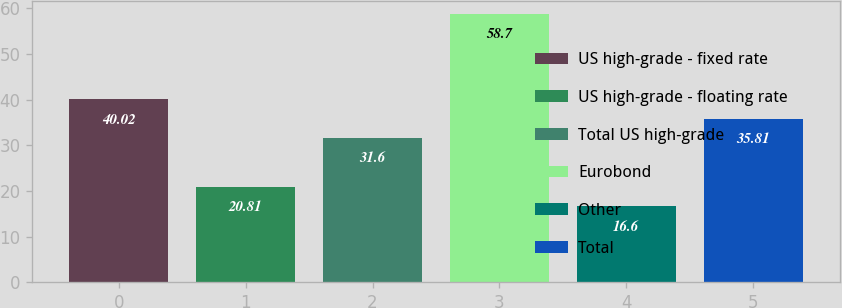<chart> <loc_0><loc_0><loc_500><loc_500><bar_chart><fcel>US high-grade - fixed rate<fcel>US high-grade - floating rate<fcel>Total US high-grade<fcel>Eurobond<fcel>Other<fcel>Total<nl><fcel>40.02<fcel>20.81<fcel>31.6<fcel>58.7<fcel>16.6<fcel>35.81<nl></chart> 